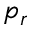<formula> <loc_0><loc_0><loc_500><loc_500>p _ { r }</formula> 